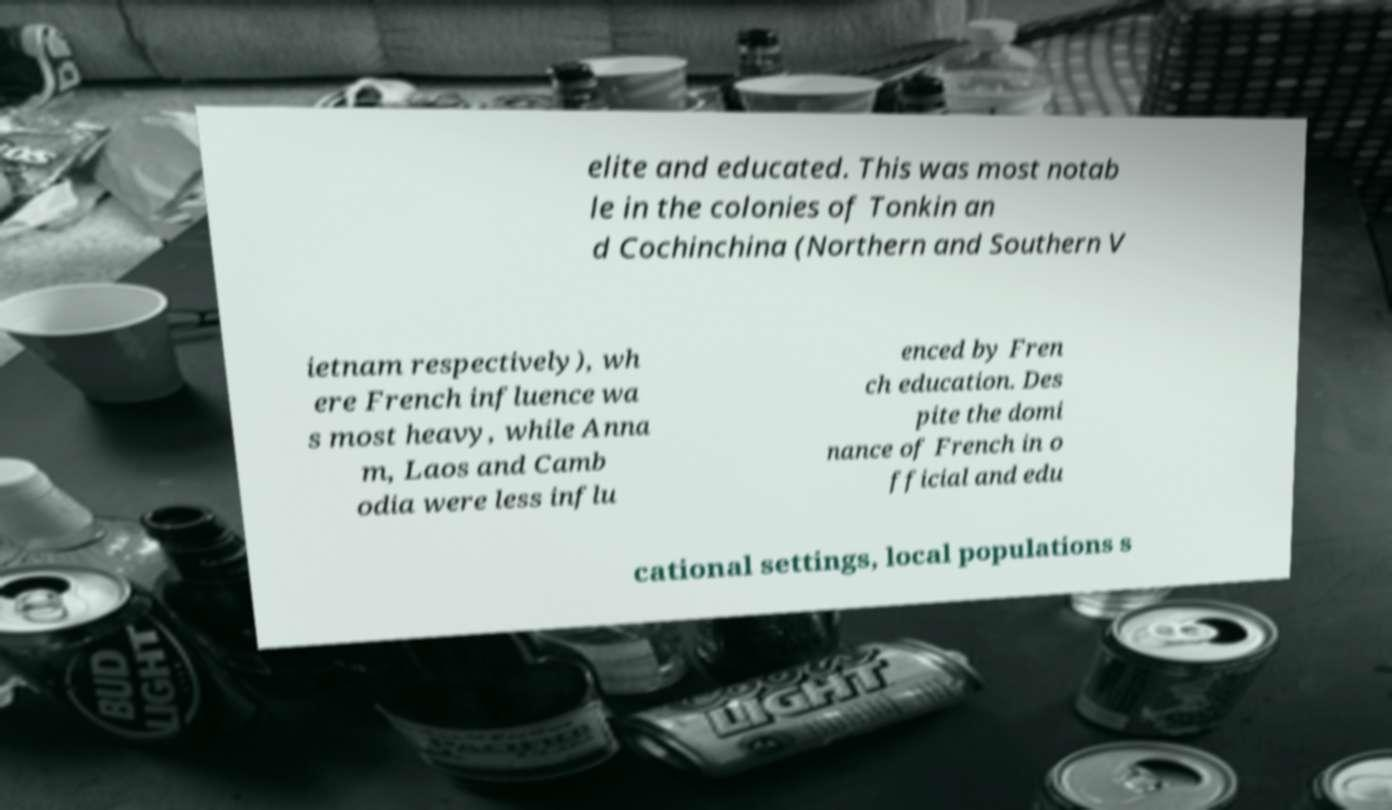I need the written content from this picture converted into text. Can you do that? elite and educated. This was most notab le in the colonies of Tonkin an d Cochinchina (Northern and Southern V ietnam respectively), wh ere French influence wa s most heavy, while Anna m, Laos and Camb odia were less influ enced by Fren ch education. Des pite the domi nance of French in o fficial and edu cational settings, local populations s 